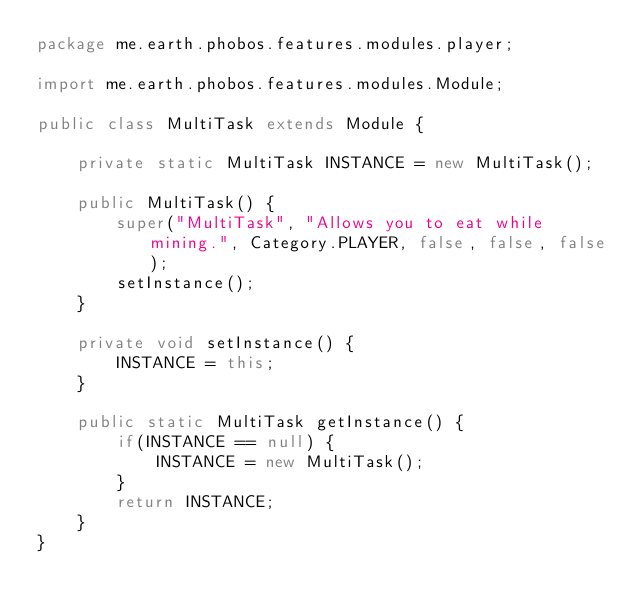<code> <loc_0><loc_0><loc_500><loc_500><_Java_>package me.earth.phobos.features.modules.player;

import me.earth.phobos.features.modules.Module;

public class MultiTask extends Module {

    private static MultiTask INSTANCE = new MultiTask();

    public MultiTask() {
        super("MultiTask", "Allows you to eat while mining.", Category.PLAYER, false, false, false);
        setInstance();
    }

    private void setInstance() {
        INSTANCE = this;
    }

    public static MultiTask getInstance() {
        if(INSTANCE == null) {
            INSTANCE = new MultiTask();
        }
        return INSTANCE;
    }
}
</code> 